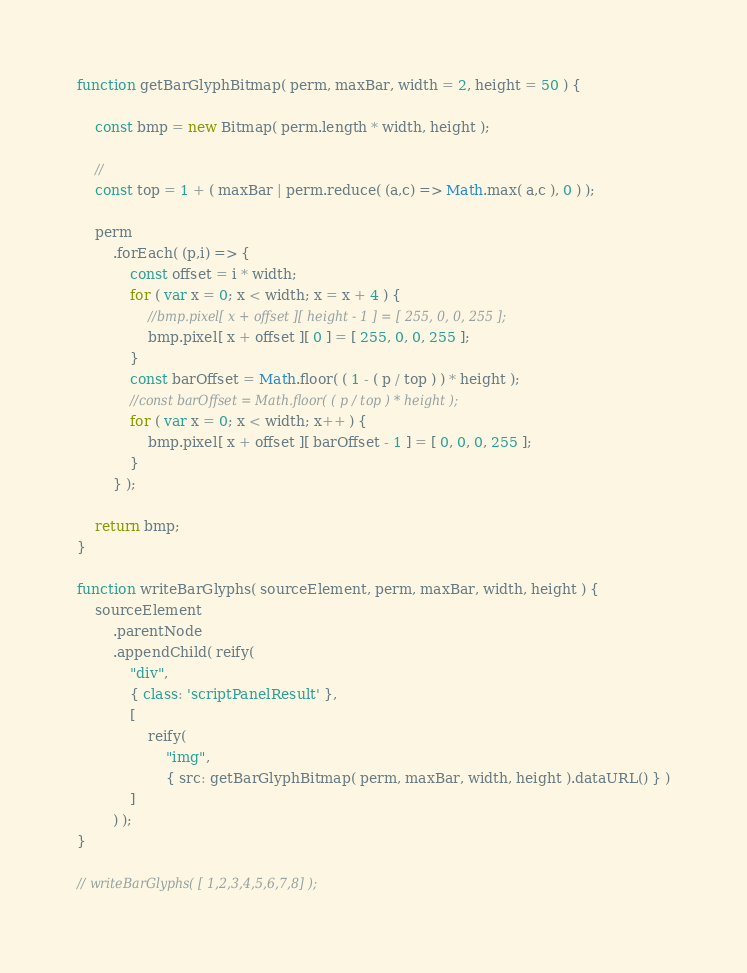Convert code to text. <code><loc_0><loc_0><loc_500><loc_500><_JavaScript_>
function getBarGlyphBitmap( perm, maxBar, width = 2, height = 50 ) {

    const bmp = new Bitmap( perm.length * width, height );

    //
    const top = 1 + ( maxBar | perm.reduce( (a,c) => Math.max( a,c ), 0 ) );

    perm
        .forEach( (p,i) => {
            const offset = i * width;
            for ( var x = 0; x < width; x = x + 4 ) {
                //bmp.pixel[ x + offset ][ height - 1 ] = [ 255, 0, 0, 255 ];
                bmp.pixel[ x + offset ][ 0 ] = [ 255, 0, 0, 255 ];
            }
            const barOffset = Math.floor( ( 1 - ( p / top ) ) * height );
            //const barOffset = Math.floor( ( p / top ) * height );
            for ( var x = 0; x < width; x++ ) {
                bmp.pixel[ x + offset ][ barOffset - 1 ] = [ 0, 0, 0, 255 ];
            }
        } );

    return bmp;
}

function writeBarGlyphs( sourceElement, perm, maxBar, width, height ) {
    sourceElement
        .parentNode
        .appendChild( reify(
            "div",
            { class: 'scriptPanelResult' },
            [
                reify(
                    "img",
                    { src: getBarGlyphBitmap( perm, maxBar, width, height ).dataURL() } )
            ]
        ) );
}

// writeBarGlyphs( [ 1,2,3,4,5,6,7,8] );</code> 